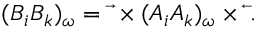<formula> <loc_0><loc_0><loc_500><loc_500>( B _ { i } B _ { k } ) _ { \omega } = \overrightarrow { \nabla } \times ( A _ { i } A _ { k } ) _ { \omega } \times \overleftarrow { \nabla } .</formula> 